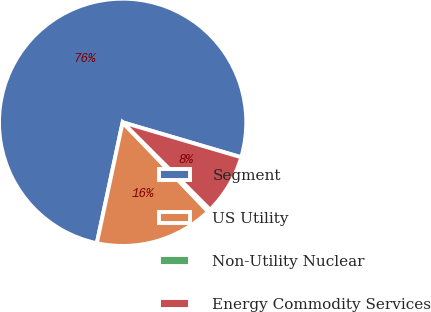<chart> <loc_0><loc_0><loc_500><loc_500><pie_chart><fcel>Segment<fcel>US Utility<fcel>Non-Utility Nuclear<fcel>Energy Commodity Services<nl><fcel>76.21%<fcel>15.52%<fcel>0.34%<fcel>7.93%<nl></chart> 